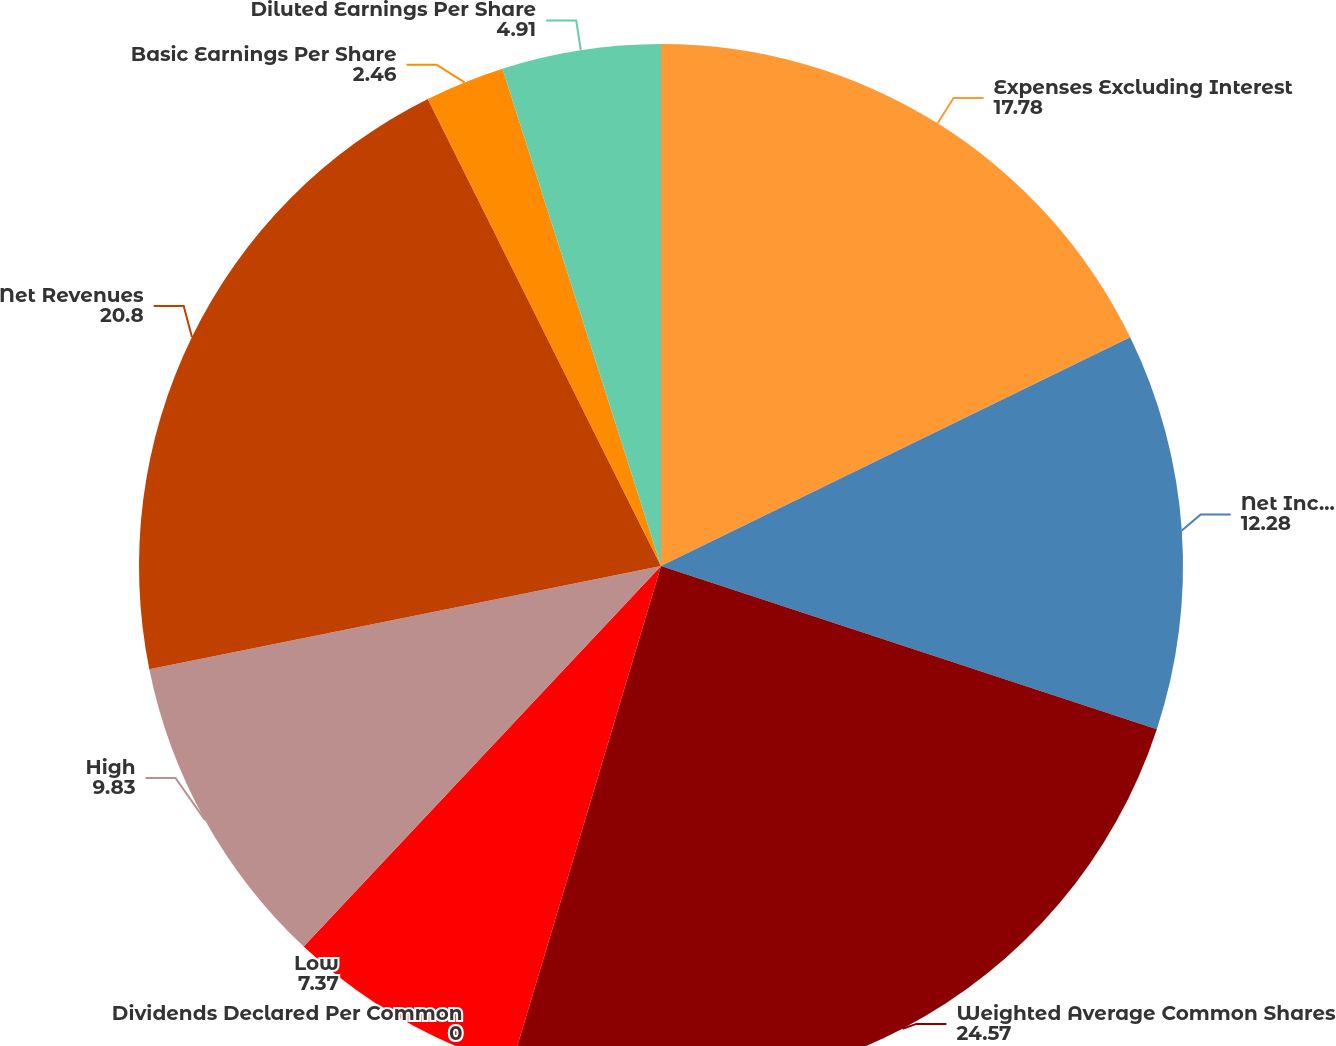Convert chart. <chart><loc_0><loc_0><loc_500><loc_500><pie_chart><fcel>Expenses Excluding Interest<fcel>Net Income<fcel>Weighted Average Common Shares<fcel>Dividends Declared Per Common<fcel>Low<fcel>High<fcel>Net Revenues<fcel>Basic Earnings Per Share<fcel>Diluted Earnings Per Share<nl><fcel>17.78%<fcel>12.28%<fcel>24.57%<fcel>0.0%<fcel>7.37%<fcel>9.83%<fcel>20.8%<fcel>2.46%<fcel>4.91%<nl></chart> 